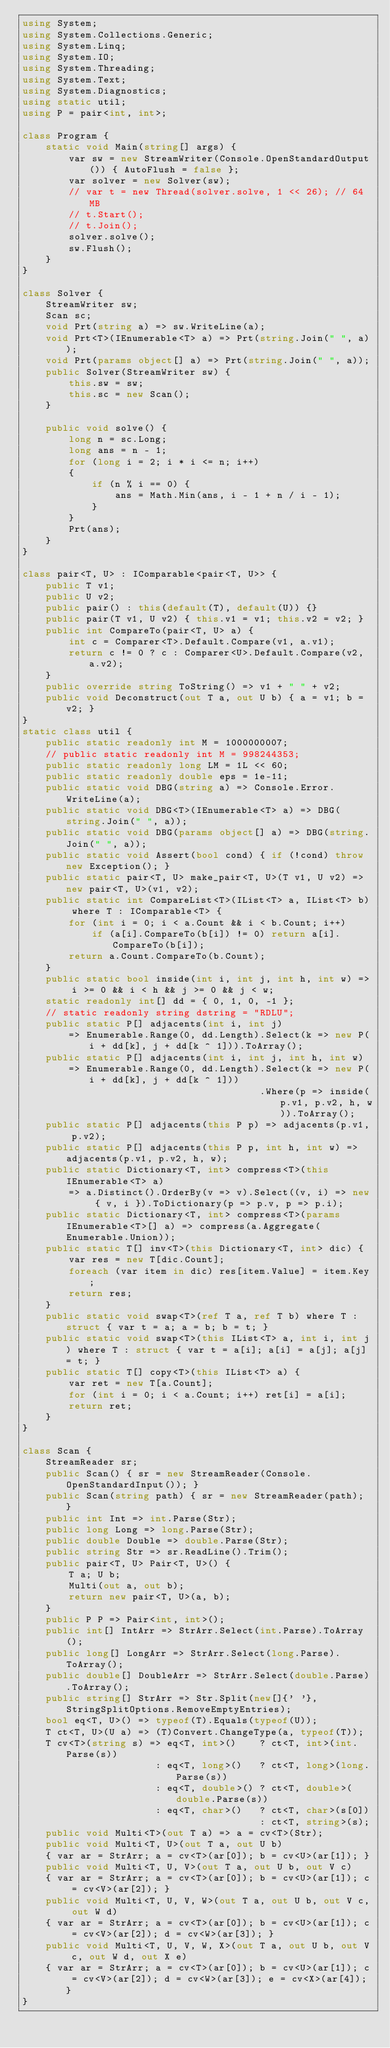Convert code to text. <code><loc_0><loc_0><loc_500><loc_500><_C#_>using System;
using System.Collections.Generic;
using System.Linq;
using System.IO;
using System.Threading;
using System.Text;
using System.Diagnostics;
using static util;
using P = pair<int, int>;

class Program {
    static void Main(string[] args) {
        var sw = new StreamWriter(Console.OpenStandardOutput()) { AutoFlush = false };
        var solver = new Solver(sw);
        // var t = new Thread(solver.solve, 1 << 26); // 64 MB
        // t.Start();
        // t.Join();
        solver.solve();
        sw.Flush();
    }
}

class Solver {
    StreamWriter sw;
    Scan sc;
    void Prt(string a) => sw.WriteLine(a);
    void Prt<T>(IEnumerable<T> a) => Prt(string.Join(" ", a));
    void Prt(params object[] a) => Prt(string.Join(" ", a));
    public Solver(StreamWriter sw) {
        this.sw = sw;
        this.sc = new Scan();
    }

    public void solve() {
        long n = sc.Long;
        long ans = n - 1;
        for (long i = 2; i * i <= n; i++)
        {
            if (n % i == 0) {
                ans = Math.Min(ans, i - 1 + n / i - 1);
            }
        }
        Prt(ans);
    }
}

class pair<T, U> : IComparable<pair<T, U>> {
    public T v1;
    public U v2;
    public pair() : this(default(T), default(U)) {}
    public pair(T v1, U v2) { this.v1 = v1; this.v2 = v2; }
    public int CompareTo(pair<T, U> a) {
        int c = Comparer<T>.Default.Compare(v1, a.v1);
        return c != 0 ? c : Comparer<U>.Default.Compare(v2, a.v2);
    }
    public override string ToString() => v1 + " " + v2;
    public void Deconstruct(out T a, out U b) { a = v1; b = v2; }
}
static class util {
    public static readonly int M = 1000000007;
    // public static readonly int M = 998244353;
    public static readonly long LM = 1L << 60;
    public static readonly double eps = 1e-11;
    public static void DBG(string a) => Console.Error.WriteLine(a);
    public static void DBG<T>(IEnumerable<T> a) => DBG(string.Join(" ", a));
    public static void DBG(params object[] a) => DBG(string.Join(" ", a));
    public static void Assert(bool cond) { if (!cond) throw new Exception(); }
    public static pair<T, U> make_pair<T, U>(T v1, U v2) => new pair<T, U>(v1, v2);
    public static int CompareList<T>(IList<T> a, IList<T> b) where T : IComparable<T> {
        for (int i = 0; i < a.Count && i < b.Count; i++)
            if (a[i].CompareTo(b[i]) != 0) return a[i].CompareTo(b[i]);
        return a.Count.CompareTo(b.Count);
    }
    public static bool inside(int i, int j, int h, int w) => i >= 0 && i < h && j >= 0 && j < w;
    static readonly int[] dd = { 0, 1, 0, -1 };
    // static readonly string dstring = "RDLU";
    public static P[] adjacents(int i, int j)
        => Enumerable.Range(0, dd.Length).Select(k => new P(i + dd[k], j + dd[k ^ 1])).ToArray();
    public static P[] adjacents(int i, int j, int h, int w)
        => Enumerable.Range(0, dd.Length).Select(k => new P(i + dd[k], j + dd[k ^ 1]))
                                         .Where(p => inside(p.v1, p.v2, h, w)).ToArray();
    public static P[] adjacents(this P p) => adjacents(p.v1, p.v2);
    public static P[] adjacents(this P p, int h, int w) => adjacents(p.v1, p.v2, h, w);
    public static Dictionary<T, int> compress<T>(this IEnumerable<T> a)
        => a.Distinct().OrderBy(v => v).Select((v, i) => new { v, i }).ToDictionary(p => p.v, p => p.i);
    public static Dictionary<T, int> compress<T>(params IEnumerable<T>[] a) => compress(a.Aggregate(Enumerable.Union));
    public static T[] inv<T>(this Dictionary<T, int> dic) {
        var res = new T[dic.Count];
        foreach (var item in dic) res[item.Value] = item.Key;
        return res;
    }
    public static void swap<T>(ref T a, ref T b) where T : struct { var t = a; a = b; b = t; }
    public static void swap<T>(this IList<T> a, int i, int j) where T : struct { var t = a[i]; a[i] = a[j]; a[j] = t; }
    public static T[] copy<T>(this IList<T> a) {
        var ret = new T[a.Count];
        for (int i = 0; i < a.Count; i++) ret[i] = a[i];
        return ret;
    }
}

class Scan {
    StreamReader sr;
    public Scan() { sr = new StreamReader(Console.OpenStandardInput()); }
    public Scan(string path) { sr = new StreamReader(path); }
    public int Int => int.Parse(Str);
    public long Long => long.Parse(Str);
    public double Double => double.Parse(Str);
    public string Str => sr.ReadLine().Trim();
    public pair<T, U> Pair<T, U>() {
        T a; U b;
        Multi(out a, out b);
        return new pair<T, U>(a, b);
    }
    public P P => Pair<int, int>();
    public int[] IntArr => StrArr.Select(int.Parse).ToArray();
    public long[] LongArr => StrArr.Select(long.Parse).ToArray();
    public double[] DoubleArr => StrArr.Select(double.Parse).ToArray();
    public string[] StrArr => Str.Split(new[]{' '}, StringSplitOptions.RemoveEmptyEntries);
    bool eq<T, U>() => typeof(T).Equals(typeof(U));
    T ct<T, U>(U a) => (T)Convert.ChangeType(a, typeof(T));
    T cv<T>(string s) => eq<T, int>()    ? ct<T, int>(int.Parse(s))
                       : eq<T, long>()   ? ct<T, long>(long.Parse(s))
                       : eq<T, double>() ? ct<T, double>(double.Parse(s))
                       : eq<T, char>()   ? ct<T, char>(s[0])
                                         : ct<T, string>(s);
    public void Multi<T>(out T a) => a = cv<T>(Str);
    public void Multi<T, U>(out T a, out U b)
    { var ar = StrArr; a = cv<T>(ar[0]); b = cv<U>(ar[1]); }
    public void Multi<T, U, V>(out T a, out U b, out V c)
    { var ar = StrArr; a = cv<T>(ar[0]); b = cv<U>(ar[1]); c = cv<V>(ar[2]); }
    public void Multi<T, U, V, W>(out T a, out U b, out V c, out W d)
    { var ar = StrArr; a = cv<T>(ar[0]); b = cv<U>(ar[1]); c = cv<V>(ar[2]); d = cv<W>(ar[3]); }
    public void Multi<T, U, V, W, X>(out T a, out U b, out V c, out W d, out X e)
    { var ar = StrArr; a = cv<T>(ar[0]); b = cv<U>(ar[1]); c = cv<V>(ar[2]); d = cv<W>(ar[3]); e = cv<X>(ar[4]); }
}
</code> 